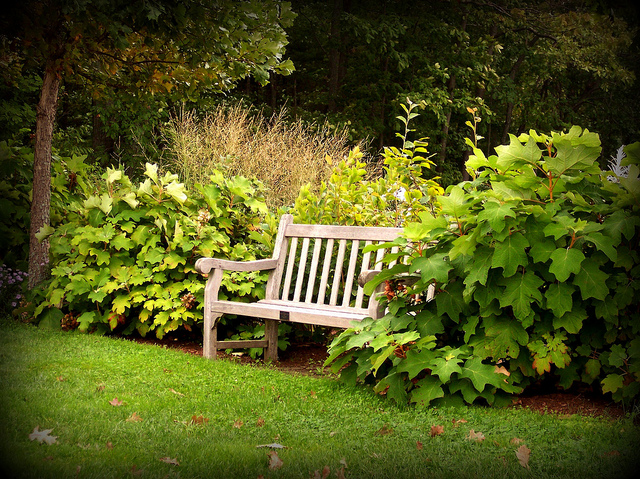<image>How many people can sit on the bench at once? It's ambiguous as to how many people can sit on the bench at once. It can accommodate 2 or 3 people, but it will depend on the size of the individuals. How many people can sit on the bench at once? I am not sure how many people can sit on the bench at once. It depends on the size of the people. 